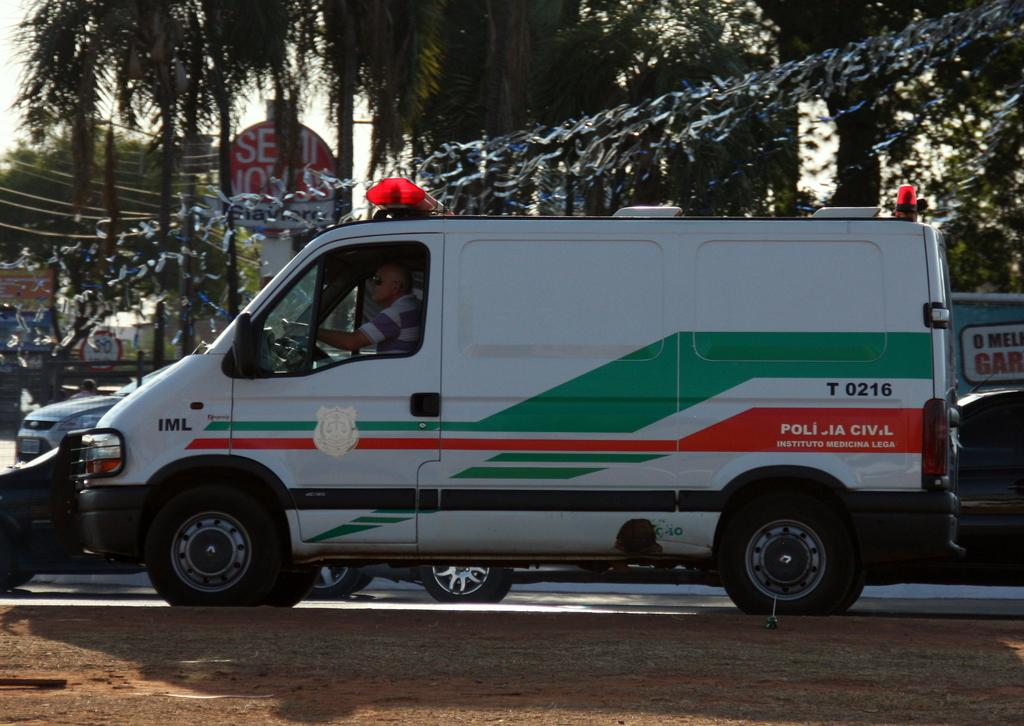<image>
Give a short and clear explanation of the subsequent image. A white van with lights on top and the marking of Policia Civil 